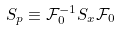Convert formula to latex. <formula><loc_0><loc_0><loc_500><loc_500>S _ { p } \equiv \mathcal { F } _ { 0 } ^ { - 1 } S _ { x } { \mathcal { F } } _ { 0 }</formula> 